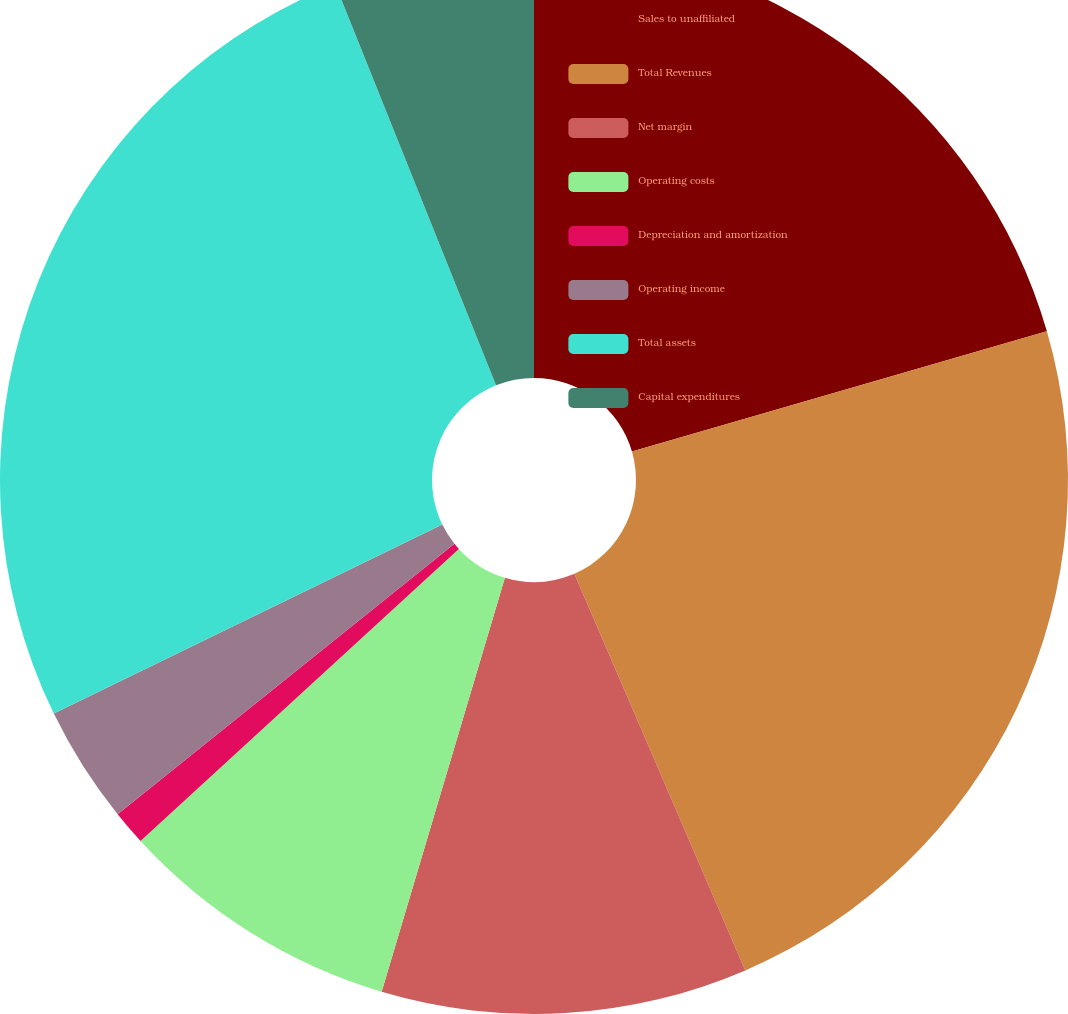Convert chart to OTSL. <chart><loc_0><loc_0><loc_500><loc_500><pie_chart><fcel>Sales to unaffiliated<fcel>Total Revenues<fcel>Net margin<fcel>Operating costs<fcel>Depreciation and amortization<fcel>Operating income<fcel>Total assets<fcel>Capital expenditures<nl><fcel>20.51%<fcel>23.02%<fcel>11.08%<fcel>8.58%<fcel>1.05%<fcel>3.56%<fcel>26.14%<fcel>6.07%<nl></chart> 